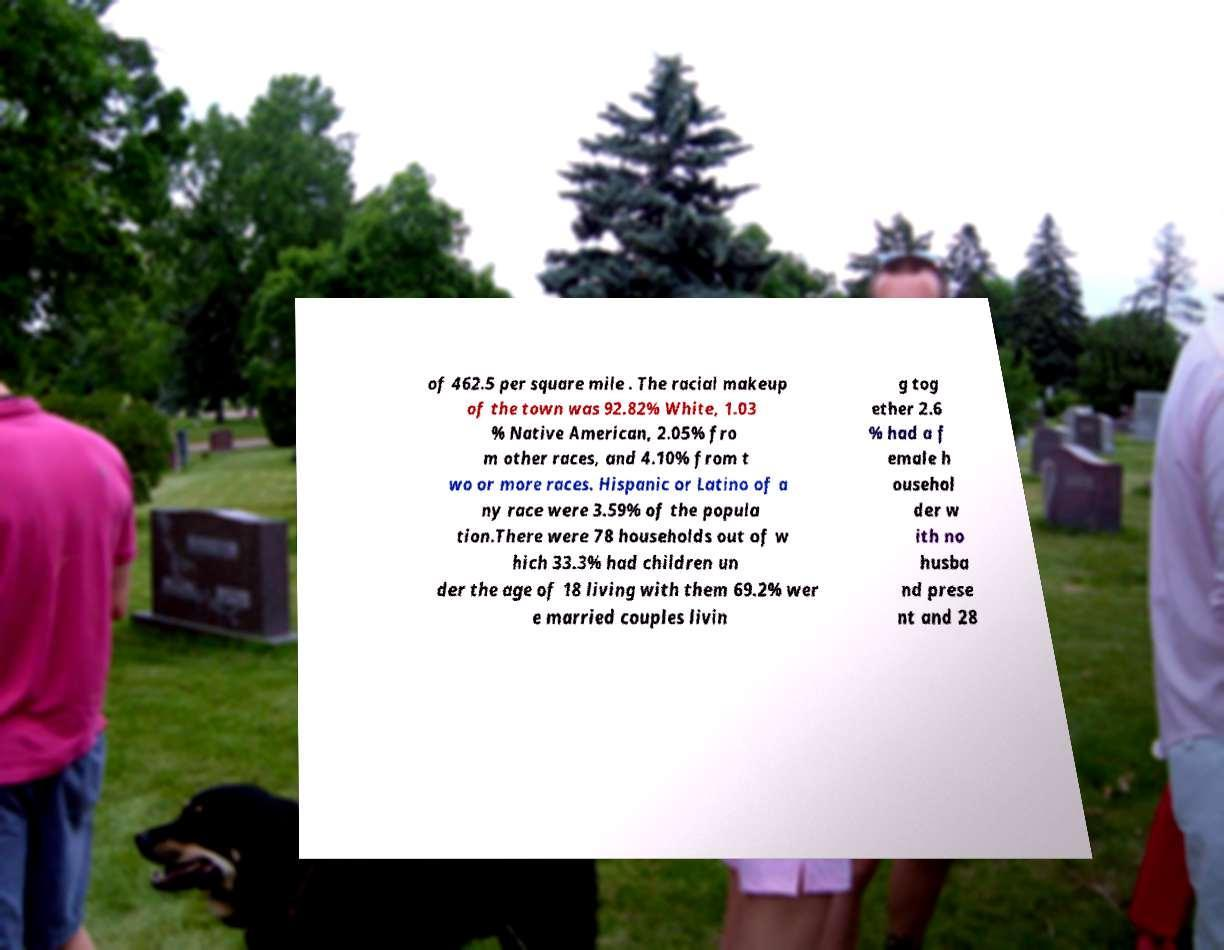What messages or text are displayed in this image? I need them in a readable, typed format. of 462.5 per square mile . The racial makeup of the town was 92.82% White, 1.03 % Native American, 2.05% fro m other races, and 4.10% from t wo or more races. Hispanic or Latino of a ny race were 3.59% of the popula tion.There were 78 households out of w hich 33.3% had children un der the age of 18 living with them 69.2% wer e married couples livin g tog ether 2.6 % had a f emale h ousehol der w ith no husba nd prese nt and 28 